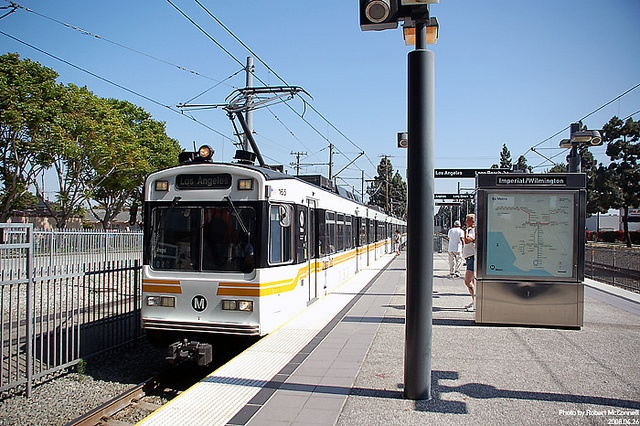Describe the objects in this image and their specific colors. I can see train in gray, black, white, and darkgray tones, traffic light in gray and black tones, people in gray, darkgray, lightgray, and black tones, people in gray, darkgray, and lightgray tones, and people in gray, black, navy, and darkblue tones in this image. 